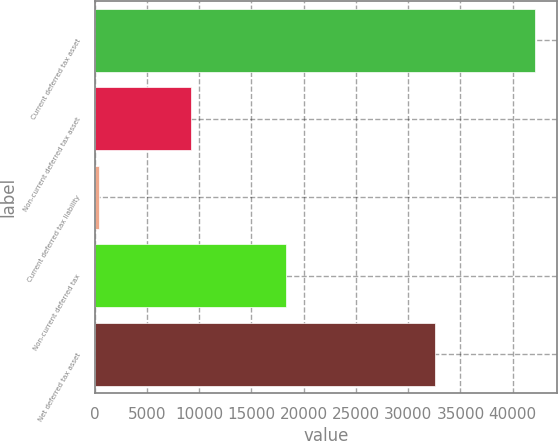Convert chart. <chart><loc_0><loc_0><loc_500><loc_500><bar_chart><fcel>Current deferred tax asset<fcel>Non-current deferred tax asset<fcel>Current deferred tax liability<fcel>Non-current deferred tax<fcel>Net deferred tax asset<nl><fcel>42109<fcel>9206<fcel>415<fcel>18297<fcel>32603<nl></chart> 